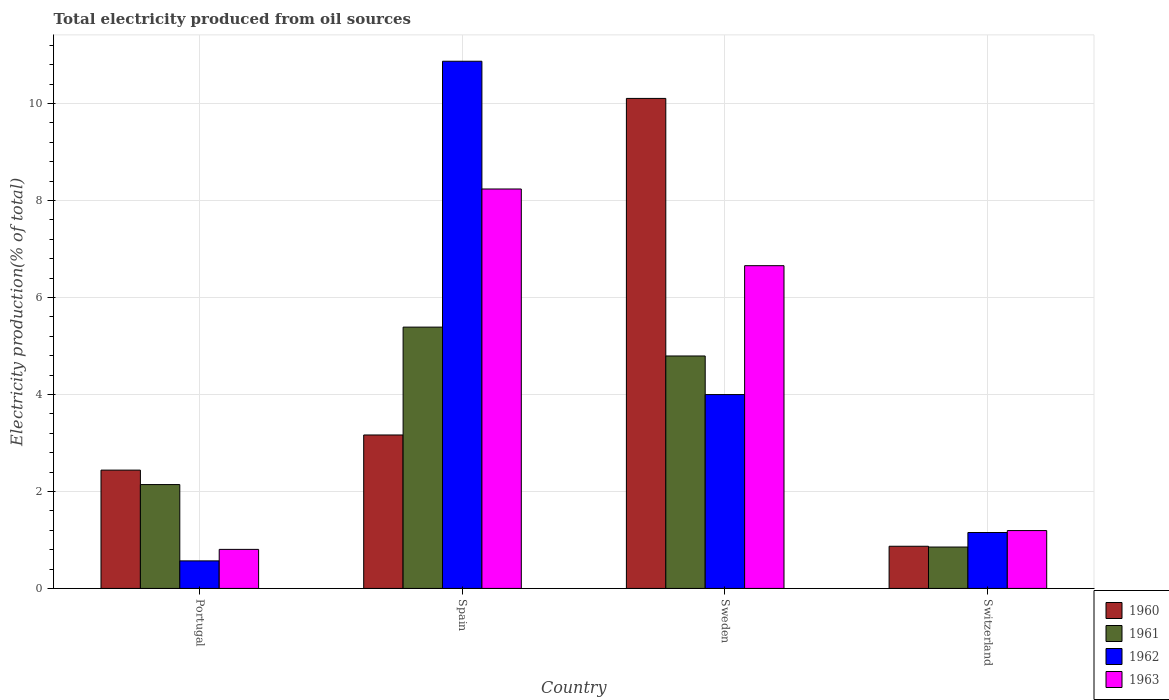How many groups of bars are there?
Make the answer very short. 4. Are the number of bars per tick equal to the number of legend labels?
Ensure brevity in your answer.  Yes. Are the number of bars on each tick of the X-axis equal?
Keep it short and to the point. Yes. What is the label of the 1st group of bars from the left?
Your answer should be compact. Portugal. What is the total electricity produced in 1963 in Spain?
Make the answer very short. 8.24. Across all countries, what is the maximum total electricity produced in 1961?
Offer a very short reply. 5.39. Across all countries, what is the minimum total electricity produced in 1961?
Your response must be concise. 0.85. In which country was the total electricity produced in 1962 maximum?
Your response must be concise. Spain. In which country was the total electricity produced in 1960 minimum?
Offer a terse response. Switzerland. What is the total total electricity produced in 1962 in the graph?
Provide a short and direct response. 16.59. What is the difference between the total electricity produced in 1963 in Portugal and that in Sweden?
Make the answer very short. -5.85. What is the difference between the total electricity produced in 1963 in Switzerland and the total electricity produced in 1961 in Spain?
Provide a short and direct response. -4.2. What is the average total electricity produced in 1961 per country?
Your response must be concise. 3.29. What is the difference between the total electricity produced of/in 1960 and total electricity produced of/in 1961 in Sweden?
Make the answer very short. 5.31. What is the ratio of the total electricity produced in 1963 in Portugal to that in Switzerland?
Make the answer very short. 0.67. What is the difference between the highest and the second highest total electricity produced in 1961?
Give a very brief answer. -2.65. What is the difference between the highest and the lowest total electricity produced in 1961?
Your answer should be very brief. 4.53. In how many countries, is the total electricity produced in 1961 greater than the average total electricity produced in 1961 taken over all countries?
Provide a succinct answer. 2. Is it the case that in every country, the sum of the total electricity produced in 1963 and total electricity produced in 1962 is greater than the total electricity produced in 1961?
Your answer should be very brief. No. How many bars are there?
Provide a short and direct response. 16. Are all the bars in the graph horizontal?
Offer a terse response. No. What is the difference between two consecutive major ticks on the Y-axis?
Give a very brief answer. 2. Are the values on the major ticks of Y-axis written in scientific E-notation?
Keep it short and to the point. No. Does the graph contain any zero values?
Offer a very short reply. No. Where does the legend appear in the graph?
Ensure brevity in your answer.  Bottom right. How many legend labels are there?
Your response must be concise. 4. What is the title of the graph?
Your answer should be compact. Total electricity produced from oil sources. Does "2012" appear as one of the legend labels in the graph?
Your response must be concise. No. What is the Electricity production(% of total) in 1960 in Portugal?
Provide a short and direct response. 2.44. What is the Electricity production(% of total) of 1961 in Portugal?
Provide a short and direct response. 2.14. What is the Electricity production(% of total) of 1962 in Portugal?
Ensure brevity in your answer.  0.57. What is the Electricity production(% of total) of 1963 in Portugal?
Your answer should be very brief. 0.81. What is the Electricity production(% of total) of 1960 in Spain?
Your answer should be very brief. 3.16. What is the Electricity production(% of total) in 1961 in Spain?
Offer a terse response. 5.39. What is the Electricity production(% of total) of 1962 in Spain?
Offer a terse response. 10.87. What is the Electricity production(% of total) in 1963 in Spain?
Keep it short and to the point. 8.24. What is the Electricity production(% of total) of 1960 in Sweden?
Provide a short and direct response. 10.1. What is the Electricity production(% of total) of 1961 in Sweden?
Give a very brief answer. 4.79. What is the Electricity production(% of total) of 1962 in Sweden?
Your response must be concise. 4. What is the Electricity production(% of total) of 1963 in Sweden?
Keep it short and to the point. 6.66. What is the Electricity production(% of total) in 1960 in Switzerland?
Ensure brevity in your answer.  0.87. What is the Electricity production(% of total) of 1961 in Switzerland?
Ensure brevity in your answer.  0.85. What is the Electricity production(% of total) of 1962 in Switzerland?
Your answer should be compact. 1.15. What is the Electricity production(% of total) of 1963 in Switzerland?
Provide a succinct answer. 1.19. Across all countries, what is the maximum Electricity production(% of total) of 1960?
Give a very brief answer. 10.1. Across all countries, what is the maximum Electricity production(% of total) in 1961?
Make the answer very short. 5.39. Across all countries, what is the maximum Electricity production(% of total) in 1962?
Keep it short and to the point. 10.87. Across all countries, what is the maximum Electricity production(% of total) of 1963?
Offer a terse response. 8.24. Across all countries, what is the minimum Electricity production(% of total) in 1960?
Offer a very short reply. 0.87. Across all countries, what is the minimum Electricity production(% of total) in 1961?
Make the answer very short. 0.85. Across all countries, what is the minimum Electricity production(% of total) of 1962?
Keep it short and to the point. 0.57. Across all countries, what is the minimum Electricity production(% of total) in 1963?
Provide a short and direct response. 0.81. What is the total Electricity production(% of total) in 1960 in the graph?
Offer a terse response. 16.58. What is the total Electricity production(% of total) of 1961 in the graph?
Make the answer very short. 13.18. What is the total Electricity production(% of total) of 1962 in the graph?
Your answer should be compact. 16.59. What is the total Electricity production(% of total) in 1963 in the graph?
Keep it short and to the point. 16.89. What is the difference between the Electricity production(% of total) in 1960 in Portugal and that in Spain?
Provide a succinct answer. -0.72. What is the difference between the Electricity production(% of total) of 1961 in Portugal and that in Spain?
Your response must be concise. -3.25. What is the difference between the Electricity production(% of total) of 1962 in Portugal and that in Spain?
Ensure brevity in your answer.  -10.3. What is the difference between the Electricity production(% of total) in 1963 in Portugal and that in Spain?
Offer a terse response. -7.43. What is the difference between the Electricity production(% of total) of 1960 in Portugal and that in Sweden?
Provide a succinct answer. -7.66. What is the difference between the Electricity production(% of total) of 1961 in Portugal and that in Sweden?
Offer a very short reply. -2.65. What is the difference between the Electricity production(% of total) of 1962 in Portugal and that in Sweden?
Your answer should be compact. -3.43. What is the difference between the Electricity production(% of total) of 1963 in Portugal and that in Sweden?
Your answer should be very brief. -5.85. What is the difference between the Electricity production(% of total) in 1960 in Portugal and that in Switzerland?
Offer a very short reply. 1.57. What is the difference between the Electricity production(% of total) in 1961 in Portugal and that in Switzerland?
Make the answer very short. 1.29. What is the difference between the Electricity production(% of total) in 1962 in Portugal and that in Switzerland?
Ensure brevity in your answer.  -0.59. What is the difference between the Electricity production(% of total) of 1963 in Portugal and that in Switzerland?
Your answer should be very brief. -0.39. What is the difference between the Electricity production(% of total) of 1960 in Spain and that in Sweden?
Keep it short and to the point. -6.94. What is the difference between the Electricity production(% of total) of 1961 in Spain and that in Sweden?
Provide a short and direct response. 0.6. What is the difference between the Electricity production(% of total) of 1962 in Spain and that in Sweden?
Ensure brevity in your answer.  6.87. What is the difference between the Electricity production(% of total) in 1963 in Spain and that in Sweden?
Provide a succinct answer. 1.58. What is the difference between the Electricity production(% of total) in 1960 in Spain and that in Switzerland?
Your answer should be very brief. 2.29. What is the difference between the Electricity production(% of total) in 1961 in Spain and that in Switzerland?
Offer a very short reply. 4.53. What is the difference between the Electricity production(% of total) in 1962 in Spain and that in Switzerland?
Your answer should be compact. 9.72. What is the difference between the Electricity production(% of total) of 1963 in Spain and that in Switzerland?
Your response must be concise. 7.04. What is the difference between the Electricity production(% of total) of 1960 in Sweden and that in Switzerland?
Ensure brevity in your answer.  9.23. What is the difference between the Electricity production(% of total) in 1961 in Sweden and that in Switzerland?
Make the answer very short. 3.94. What is the difference between the Electricity production(% of total) of 1962 in Sweden and that in Switzerland?
Your answer should be very brief. 2.84. What is the difference between the Electricity production(% of total) of 1963 in Sweden and that in Switzerland?
Offer a terse response. 5.46. What is the difference between the Electricity production(% of total) of 1960 in Portugal and the Electricity production(% of total) of 1961 in Spain?
Offer a very short reply. -2.95. What is the difference between the Electricity production(% of total) in 1960 in Portugal and the Electricity production(% of total) in 1962 in Spain?
Provide a short and direct response. -8.43. What is the difference between the Electricity production(% of total) of 1960 in Portugal and the Electricity production(% of total) of 1963 in Spain?
Provide a succinct answer. -5.8. What is the difference between the Electricity production(% of total) in 1961 in Portugal and the Electricity production(% of total) in 1962 in Spain?
Provide a succinct answer. -8.73. What is the difference between the Electricity production(% of total) of 1961 in Portugal and the Electricity production(% of total) of 1963 in Spain?
Keep it short and to the point. -6.09. What is the difference between the Electricity production(% of total) of 1962 in Portugal and the Electricity production(% of total) of 1963 in Spain?
Ensure brevity in your answer.  -7.67. What is the difference between the Electricity production(% of total) of 1960 in Portugal and the Electricity production(% of total) of 1961 in Sweden?
Make the answer very short. -2.35. What is the difference between the Electricity production(% of total) of 1960 in Portugal and the Electricity production(% of total) of 1962 in Sweden?
Provide a short and direct response. -1.56. What is the difference between the Electricity production(% of total) in 1960 in Portugal and the Electricity production(% of total) in 1963 in Sweden?
Ensure brevity in your answer.  -4.22. What is the difference between the Electricity production(% of total) of 1961 in Portugal and the Electricity production(% of total) of 1962 in Sweden?
Your answer should be compact. -1.86. What is the difference between the Electricity production(% of total) in 1961 in Portugal and the Electricity production(% of total) in 1963 in Sweden?
Provide a short and direct response. -4.51. What is the difference between the Electricity production(% of total) in 1962 in Portugal and the Electricity production(% of total) in 1963 in Sweden?
Make the answer very short. -6.09. What is the difference between the Electricity production(% of total) in 1960 in Portugal and the Electricity production(% of total) in 1961 in Switzerland?
Your answer should be compact. 1.59. What is the difference between the Electricity production(% of total) of 1960 in Portugal and the Electricity production(% of total) of 1962 in Switzerland?
Offer a terse response. 1.29. What is the difference between the Electricity production(% of total) of 1960 in Portugal and the Electricity production(% of total) of 1963 in Switzerland?
Make the answer very short. 1.25. What is the difference between the Electricity production(% of total) of 1961 in Portugal and the Electricity production(% of total) of 1962 in Switzerland?
Your answer should be very brief. 0.99. What is the difference between the Electricity production(% of total) of 1961 in Portugal and the Electricity production(% of total) of 1963 in Switzerland?
Keep it short and to the point. 0.95. What is the difference between the Electricity production(% of total) in 1962 in Portugal and the Electricity production(% of total) in 1963 in Switzerland?
Offer a terse response. -0.63. What is the difference between the Electricity production(% of total) in 1960 in Spain and the Electricity production(% of total) in 1961 in Sweden?
Give a very brief answer. -1.63. What is the difference between the Electricity production(% of total) in 1960 in Spain and the Electricity production(% of total) in 1962 in Sweden?
Provide a succinct answer. -0.83. What is the difference between the Electricity production(% of total) in 1960 in Spain and the Electricity production(% of total) in 1963 in Sweden?
Your answer should be compact. -3.49. What is the difference between the Electricity production(% of total) in 1961 in Spain and the Electricity production(% of total) in 1962 in Sweden?
Offer a terse response. 1.39. What is the difference between the Electricity production(% of total) of 1961 in Spain and the Electricity production(% of total) of 1963 in Sweden?
Provide a succinct answer. -1.27. What is the difference between the Electricity production(% of total) of 1962 in Spain and the Electricity production(% of total) of 1963 in Sweden?
Provide a succinct answer. 4.22. What is the difference between the Electricity production(% of total) in 1960 in Spain and the Electricity production(% of total) in 1961 in Switzerland?
Offer a very short reply. 2.31. What is the difference between the Electricity production(% of total) in 1960 in Spain and the Electricity production(% of total) in 1962 in Switzerland?
Provide a short and direct response. 2.01. What is the difference between the Electricity production(% of total) in 1960 in Spain and the Electricity production(% of total) in 1963 in Switzerland?
Provide a short and direct response. 1.97. What is the difference between the Electricity production(% of total) of 1961 in Spain and the Electricity production(% of total) of 1962 in Switzerland?
Provide a short and direct response. 4.24. What is the difference between the Electricity production(% of total) of 1961 in Spain and the Electricity production(% of total) of 1963 in Switzerland?
Offer a terse response. 4.2. What is the difference between the Electricity production(% of total) of 1962 in Spain and the Electricity production(% of total) of 1963 in Switzerland?
Your response must be concise. 9.68. What is the difference between the Electricity production(% of total) of 1960 in Sweden and the Electricity production(% of total) of 1961 in Switzerland?
Keep it short and to the point. 9.25. What is the difference between the Electricity production(% of total) in 1960 in Sweden and the Electricity production(% of total) in 1962 in Switzerland?
Provide a succinct answer. 8.95. What is the difference between the Electricity production(% of total) of 1960 in Sweden and the Electricity production(% of total) of 1963 in Switzerland?
Provide a short and direct response. 8.91. What is the difference between the Electricity production(% of total) of 1961 in Sweden and the Electricity production(% of total) of 1962 in Switzerland?
Your response must be concise. 3.64. What is the difference between the Electricity production(% of total) of 1962 in Sweden and the Electricity production(% of total) of 1963 in Switzerland?
Make the answer very short. 2.8. What is the average Electricity production(% of total) in 1960 per country?
Keep it short and to the point. 4.14. What is the average Electricity production(% of total) in 1961 per country?
Offer a very short reply. 3.29. What is the average Electricity production(% of total) in 1962 per country?
Keep it short and to the point. 4.15. What is the average Electricity production(% of total) in 1963 per country?
Provide a succinct answer. 4.22. What is the difference between the Electricity production(% of total) of 1960 and Electricity production(% of total) of 1961 in Portugal?
Ensure brevity in your answer.  0.3. What is the difference between the Electricity production(% of total) in 1960 and Electricity production(% of total) in 1962 in Portugal?
Your answer should be very brief. 1.87. What is the difference between the Electricity production(% of total) in 1960 and Electricity production(% of total) in 1963 in Portugal?
Offer a very short reply. 1.63. What is the difference between the Electricity production(% of total) in 1961 and Electricity production(% of total) in 1962 in Portugal?
Your answer should be very brief. 1.57. What is the difference between the Electricity production(% of total) of 1961 and Electricity production(% of total) of 1963 in Portugal?
Provide a short and direct response. 1.34. What is the difference between the Electricity production(% of total) of 1962 and Electricity production(% of total) of 1963 in Portugal?
Provide a short and direct response. -0.24. What is the difference between the Electricity production(% of total) in 1960 and Electricity production(% of total) in 1961 in Spain?
Your answer should be very brief. -2.22. What is the difference between the Electricity production(% of total) in 1960 and Electricity production(% of total) in 1962 in Spain?
Make the answer very short. -7.71. What is the difference between the Electricity production(% of total) in 1960 and Electricity production(% of total) in 1963 in Spain?
Keep it short and to the point. -5.07. What is the difference between the Electricity production(% of total) in 1961 and Electricity production(% of total) in 1962 in Spain?
Give a very brief answer. -5.48. What is the difference between the Electricity production(% of total) in 1961 and Electricity production(% of total) in 1963 in Spain?
Give a very brief answer. -2.85. What is the difference between the Electricity production(% of total) in 1962 and Electricity production(% of total) in 1963 in Spain?
Your answer should be very brief. 2.63. What is the difference between the Electricity production(% of total) of 1960 and Electricity production(% of total) of 1961 in Sweden?
Your answer should be very brief. 5.31. What is the difference between the Electricity production(% of total) in 1960 and Electricity production(% of total) in 1962 in Sweden?
Provide a short and direct response. 6.11. What is the difference between the Electricity production(% of total) in 1960 and Electricity production(% of total) in 1963 in Sweden?
Ensure brevity in your answer.  3.45. What is the difference between the Electricity production(% of total) of 1961 and Electricity production(% of total) of 1962 in Sweden?
Keep it short and to the point. 0.8. What is the difference between the Electricity production(% of total) in 1961 and Electricity production(% of total) in 1963 in Sweden?
Your answer should be compact. -1.86. What is the difference between the Electricity production(% of total) in 1962 and Electricity production(% of total) in 1963 in Sweden?
Offer a very short reply. -2.66. What is the difference between the Electricity production(% of total) in 1960 and Electricity production(% of total) in 1961 in Switzerland?
Provide a short and direct response. 0.02. What is the difference between the Electricity production(% of total) in 1960 and Electricity production(% of total) in 1962 in Switzerland?
Offer a very short reply. -0.28. What is the difference between the Electricity production(% of total) of 1960 and Electricity production(% of total) of 1963 in Switzerland?
Your answer should be compact. -0.32. What is the difference between the Electricity production(% of total) in 1961 and Electricity production(% of total) in 1962 in Switzerland?
Ensure brevity in your answer.  -0.3. What is the difference between the Electricity production(% of total) of 1961 and Electricity production(% of total) of 1963 in Switzerland?
Your response must be concise. -0.34. What is the difference between the Electricity production(% of total) of 1962 and Electricity production(% of total) of 1963 in Switzerland?
Offer a terse response. -0.04. What is the ratio of the Electricity production(% of total) of 1960 in Portugal to that in Spain?
Provide a succinct answer. 0.77. What is the ratio of the Electricity production(% of total) of 1961 in Portugal to that in Spain?
Your response must be concise. 0.4. What is the ratio of the Electricity production(% of total) in 1962 in Portugal to that in Spain?
Provide a short and direct response. 0.05. What is the ratio of the Electricity production(% of total) in 1963 in Portugal to that in Spain?
Offer a terse response. 0.1. What is the ratio of the Electricity production(% of total) of 1960 in Portugal to that in Sweden?
Your answer should be very brief. 0.24. What is the ratio of the Electricity production(% of total) in 1961 in Portugal to that in Sweden?
Ensure brevity in your answer.  0.45. What is the ratio of the Electricity production(% of total) in 1962 in Portugal to that in Sweden?
Offer a very short reply. 0.14. What is the ratio of the Electricity production(% of total) of 1963 in Portugal to that in Sweden?
Ensure brevity in your answer.  0.12. What is the ratio of the Electricity production(% of total) of 1960 in Portugal to that in Switzerland?
Offer a terse response. 2.81. What is the ratio of the Electricity production(% of total) of 1961 in Portugal to that in Switzerland?
Your answer should be compact. 2.51. What is the ratio of the Electricity production(% of total) of 1962 in Portugal to that in Switzerland?
Provide a short and direct response. 0.49. What is the ratio of the Electricity production(% of total) in 1963 in Portugal to that in Switzerland?
Give a very brief answer. 0.67. What is the ratio of the Electricity production(% of total) of 1960 in Spain to that in Sweden?
Provide a succinct answer. 0.31. What is the ratio of the Electricity production(% of total) of 1961 in Spain to that in Sweden?
Provide a succinct answer. 1.12. What is the ratio of the Electricity production(% of total) in 1962 in Spain to that in Sweden?
Make the answer very short. 2.72. What is the ratio of the Electricity production(% of total) in 1963 in Spain to that in Sweden?
Your answer should be compact. 1.24. What is the ratio of the Electricity production(% of total) in 1960 in Spain to that in Switzerland?
Your answer should be compact. 3.64. What is the ratio of the Electricity production(% of total) in 1961 in Spain to that in Switzerland?
Your answer should be very brief. 6.31. What is the ratio of the Electricity production(% of total) of 1962 in Spain to that in Switzerland?
Ensure brevity in your answer.  9.43. What is the ratio of the Electricity production(% of total) of 1963 in Spain to that in Switzerland?
Your response must be concise. 6.9. What is the ratio of the Electricity production(% of total) of 1960 in Sweden to that in Switzerland?
Provide a short and direct response. 11.62. What is the ratio of the Electricity production(% of total) in 1961 in Sweden to that in Switzerland?
Provide a short and direct response. 5.62. What is the ratio of the Electricity production(% of total) of 1962 in Sweden to that in Switzerland?
Make the answer very short. 3.47. What is the ratio of the Electricity production(% of total) in 1963 in Sweden to that in Switzerland?
Offer a very short reply. 5.58. What is the difference between the highest and the second highest Electricity production(% of total) of 1960?
Offer a very short reply. 6.94. What is the difference between the highest and the second highest Electricity production(% of total) in 1961?
Ensure brevity in your answer.  0.6. What is the difference between the highest and the second highest Electricity production(% of total) of 1962?
Your answer should be compact. 6.87. What is the difference between the highest and the second highest Electricity production(% of total) of 1963?
Keep it short and to the point. 1.58. What is the difference between the highest and the lowest Electricity production(% of total) of 1960?
Your answer should be very brief. 9.23. What is the difference between the highest and the lowest Electricity production(% of total) in 1961?
Give a very brief answer. 4.53. What is the difference between the highest and the lowest Electricity production(% of total) of 1962?
Keep it short and to the point. 10.3. What is the difference between the highest and the lowest Electricity production(% of total) in 1963?
Give a very brief answer. 7.43. 